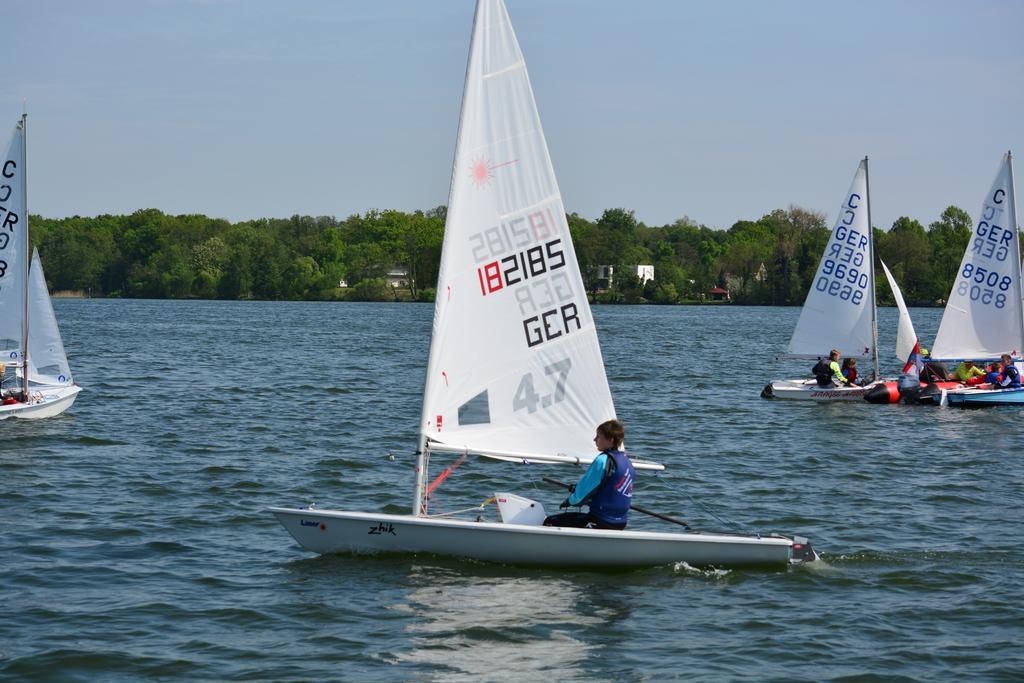Describe this image in one or two sentences. In this image there are few people dinghy sailing on the water, in the background of the image there are trees. 